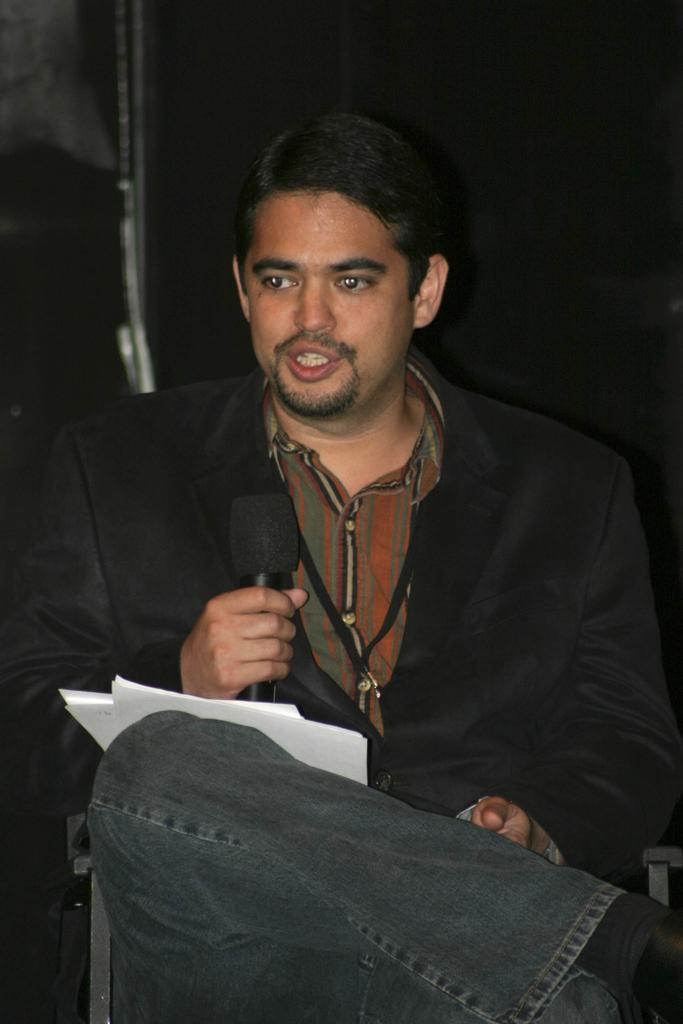Who is the main subject in the image? There is a man in the picture. What is the man doing in the image? The man is sitting on a chair and holding a mic in his hand. What can be observed about the background of the image? The background of the image is dark. Can you see a rat building a nest in the background of the image? There is no rat or nest present in the image; the background is dark. 